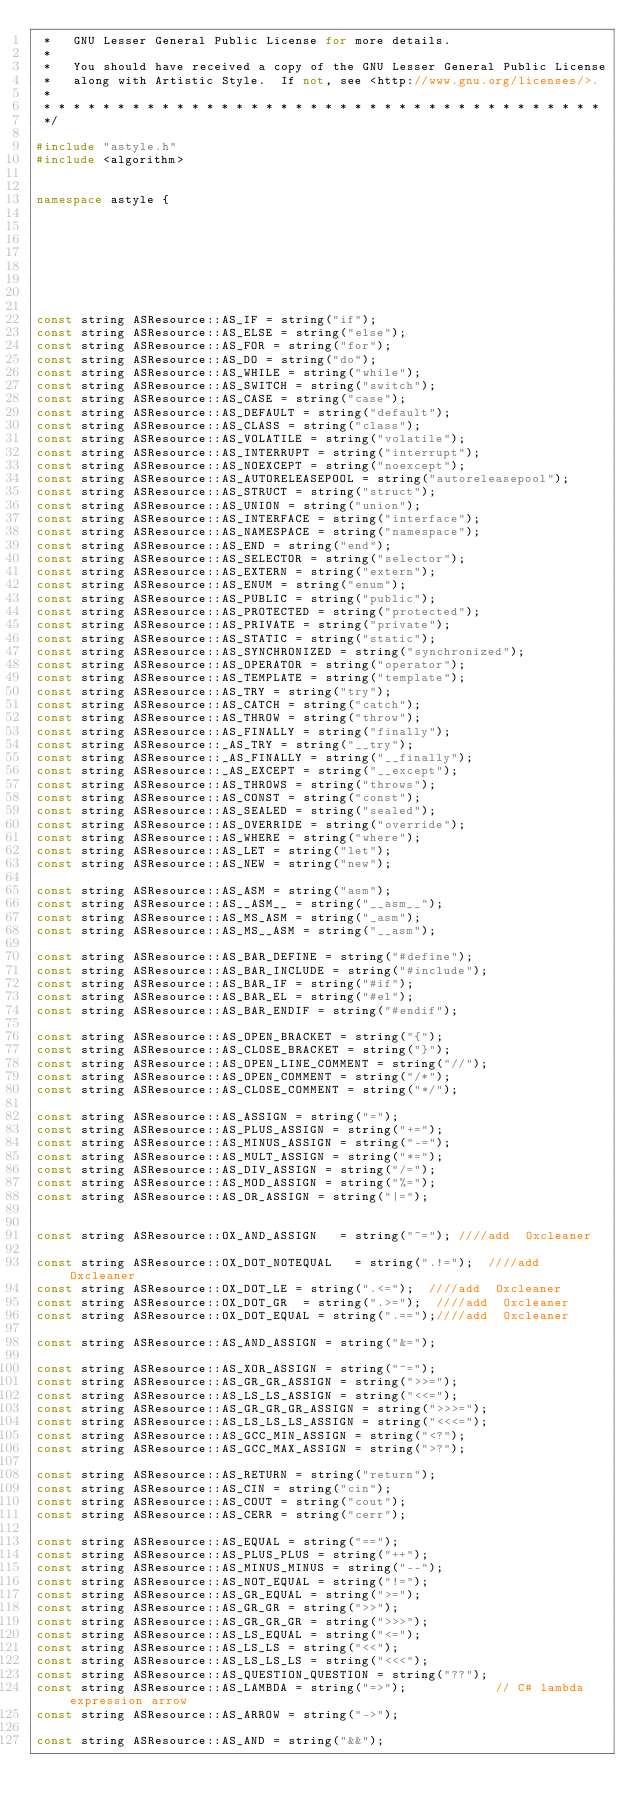Convert code to text. <code><loc_0><loc_0><loc_500><loc_500><_C++_> *   GNU Lesser General Public License for more details.
 *
 *   You should have received a copy of the GNU Lesser General Public License
 *   along with Artistic Style.  If not, see <http://www.gnu.org/licenses/>.
 *
 * * * * * * * * * * * * * * * * * * * * * * * * * * * * * * * * * * * * * *
 */

#include "astyle.h"
#include <algorithm>


namespace astyle {








const string ASResource::AS_IF = string("if");
const string ASResource::AS_ELSE = string("else");
const string ASResource::AS_FOR = string("for");
const string ASResource::AS_DO = string("do");
const string ASResource::AS_WHILE = string("while");
const string ASResource::AS_SWITCH = string("switch");
const string ASResource::AS_CASE = string("case");
const string ASResource::AS_DEFAULT = string("default");
const string ASResource::AS_CLASS = string("class");
const string ASResource::AS_VOLATILE = string("volatile");
const string ASResource::AS_INTERRUPT = string("interrupt");
const string ASResource::AS_NOEXCEPT = string("noexcept");
const string ASResource::AS_AUTORELEASEPOOL = string("autoreleasepool");
const string ASResource::AS_STRUCT = string("struct");
const string ASResource::AS_UNION = string("union");
const string ASResource::AS_INTERFACE = string("interface");
const string ASResource::AS_NAMESPACE = string("namespace");
const string ASResource::AS_END = string("end");
const string ASResource::AS_SELECTOR = string("selector");
const string ASResource::AS_EXTERN = string("extern");
const string ASResource::AS_ENUM = string("enum");
const string ASResource::AS_PUBLIC = string("public");
const string ASResource::AS_PROTECTED = string("protected");
const string ASResource::AS_PRIVATE = string("private");
const string ASResource::AS_STATIC = string("static");
const string ASResource::AS_SYNCHRONIZED = string("synchronized");
const string ASResource::AS_OPERATOR = string("operator");
const string ASResource::AS_TEMPLATE = string("template");
const string ASResource::AS_TRY = string("try");
const string ASResource::AS_CATCH = string("catch");
const string ASResource::AS_THROW = string("throw");
const string ASResource::AS_FINALLY = string("finally");
const string ASResource::_AS_TRY = string("__try");
const string ASResource::_AS_FINALLY = string("__finally");
const string ASResource::_AS_EXCEPT = string("__except");
const string ASResource::AS_THROWS = string("throws");
const string ASResource::AS_CONST = string("const");
const string ASResource::AS_SEALED = string("sealed");
const string ASResource::AS_OVERRIDE = string("override");
const string ASResource::AS_WHERE = string("where");
const string ASResource::AS_LET = string("let");
const string ASResource::AS_NEW = string("new");

const string ASResource::AS_ASM = string("asm");
const string ASResource::AS__ASM__ = string("__asm__");
const string ASResource::AS_MS_ASM = string("_asm");
const string ASResource::AS_MS__ASM = string("__asm");

const string ASResource::AS_BAR_DEFINE = string("#define");
const string ASResource::AS_BAR_INCLUDE = string("#include");
const string ASResource::AS_BAR_IF = string("#if");
const string ASResource::AS_BAR_EL = string("#el");
const string ASResource::AS_BAR_ENDIF = string("#endif");

const string ASResource::AS_OPEN_BRACKET = string("{");
const string ASResource::AS_CLOSE_BRACKET = string("}");
const string ASResource::AS_OPEN_LINE_COMMENT = string("//");
const string ASResource::AS_OPEN_COMMENT = string("/*");
const string ASResource::AS_CLOSE_COMMENT = string("*/");

const string ASResource::AS_ASSIGN = string("=");
const string ASResource::AS_PLUS_ASSIGN = string("+=");
const string ASResource::AS_MINUS_ASSIGN = string("-=");
const string ASResource::AS_MULT_ASSIGN = string("*=");
const string ASResource::AS_DIV_ASSIGN = string("/=");
const string ASResource::AS_MOD_ASSIGN = string("%=");
const string ASResource::AS_OR_ASSIGN = string("|=");


const string ASResource::OX_AND_ASSIGN   = string("~="); ////add  Oxcleaner

const string ASResource::OX_DOT_NOTEQUAL   = string(".!=");  ////add  Oxcleaner
const string ASResource::OX_DOT_LE = string(".<=");  ////add  Oxcleaner
const string ASResource::OX_DOT_GR  = string(".>=");  ////add  Oxcleaner
const string ASResource::OX_DOT_EQUAL = string(".==");////add  Oxcleaner

const string ASResource::AS_AND_ASSIGN = string("&=");

const string ASResource::AS_XOR_ASSIGN = string("^=");
const string ASResource::AS_GR_GR_ASSIGN = string(">>=");
const string ASResource::AS_LS_LS_ASSIGN = string("<<=");
const string ASResource::AS_GR_GR_GR_ASSIGN = string(">>>=");
const string ASResource::AS_LS_LS_LS_ASSIGN = string("<<<=");
const string ASResource::AS_GCC_MIN_ASSIGN = string("<?");
const string ASResource::AS_GCC_MAX_ASSIGN = string(">?");

const string ASResource::AS_RETURN = string("return");
const string ASResource::AS_CIN = string("cin");
const string ASResource::AS_COUT = string("cout");
const string ASResource::AS_CERR = string("cerr");

const string ASResource::AS_EQUAL = string("==");
const string ASResource::AS_PLUS_PLUS = string("++");
const string ASResource::AS_MINUS_MINUS = string("--");
const string ASResource::AS_NOT_EQUAL = string("!=");  
const string ASResource::AS_GR_EQUAL = string(">=");
const string ASResource::AS_GR_GR = string(">>");
const string ASResource::AS_GR_GR_GR = string(">>>");
const string ASResource::AS_LS_EQUAL = string("<=");
const string ASResource::AS_LS_LS = string("<<");
const string ASResource::AS_LS_LS_LS = string("<<<");
const string ASResource::AS_QUESTION_QUESTION = string("??");
const string ASResource::AS_LAMBDA = string("=>");            // C# lambda expression arrow
const string ASResource::AS_ARROW = string("->");

const string ASResource::AS_AND = string("&&");
 
</code> 